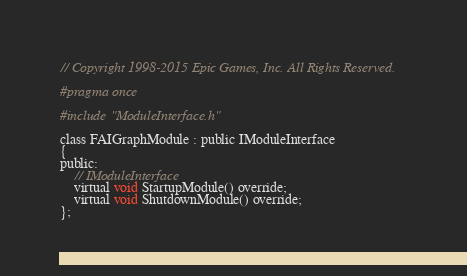Convert code to text. <code><loc_0><loc_0><loc_500><loc_500><_C_>// Copyright 1998-2015 Epic Games, Inc. All Rights Reserved.

#pragma once

#include "ModuleInterface.h"

class FAIGraphModule : public IModuleInterface
{
public:
	// IModuleInterface
	virtual void StartupModule() override;
	virtual void ShutdownModule() override;
};
</code> 